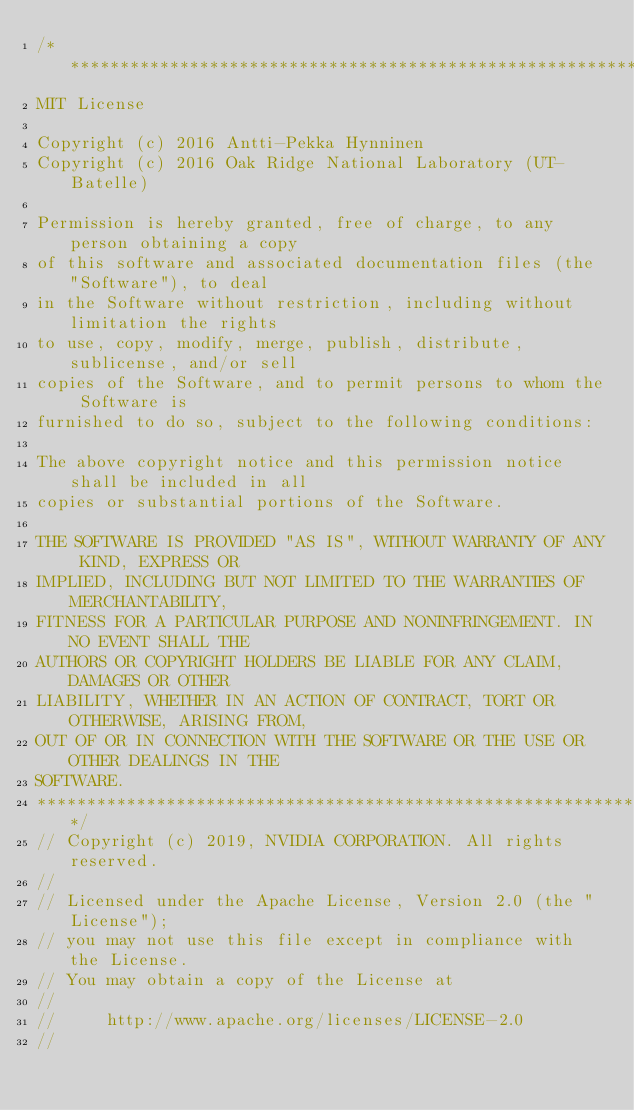Convert code to text. <code><loc_0><loc_0><loc_500><loc_500><_Cuda_>/******************************************************************************
MIT License

Copyright (c) 2016 Antti-Pekka Hynninen
Copyright (c) 2016 Oak Ridge National Laboratory (UT-Batelle)

Permission is hereby granted, free of charge, to any person obtaining a copy
of this software and associated documentation files (the "Software"), to deal
in the Software without restriction, including without limitation the rights
to use, copy, modify, merge, publish, distribute, sublicense, and/or sell
copies of the Software, and to permit persons to whom the Software is
furnished to do so, subject to the following conditions:

The above copyright notice and this permission notice shall be included in all
copies or substantial portions of the Software.

THE SOFTWARE IS PROVIDED "AS IS", WITHOUT WARRANTY OF ANY KIND, EXPRESS OR
IMPLIED, INCLUDING BUT NOT LIMITED TO THE WARRANTIES OF MERCHANTABILITY,
FITNESS FOR A PARTICULAR PURPOSE AND NONINFRINGEMENT. IN NO EVENT SHALL THE
AUTHORS OR COPYRIGHT HOLDERS BE LIABLE FOR ANY CLAIM, DAMAGES OR OTHER
LIABILITY, WHETHER IN AN ACTION OF CONTRACT, TORT OR OTHERWISE, ARISING FROM,
OUT OF OR IN CONNECTION WITH THE SOFTWARE OR THE USE OR OTHER DEALINGS IN THE
SOFTWARE.
*******************************************************************************/
// Copyright (c) 2019, NVIDIA CORPORATION. All rights reserved.
//
// Licensed under the Apache License, Version 2.0 (the "License");
// you may not use this file except in compliance with the License.
// You may obtain a copy of the License at
//
//     http://www.apache.org/licenses/LICENSE-2.0
//</code> 